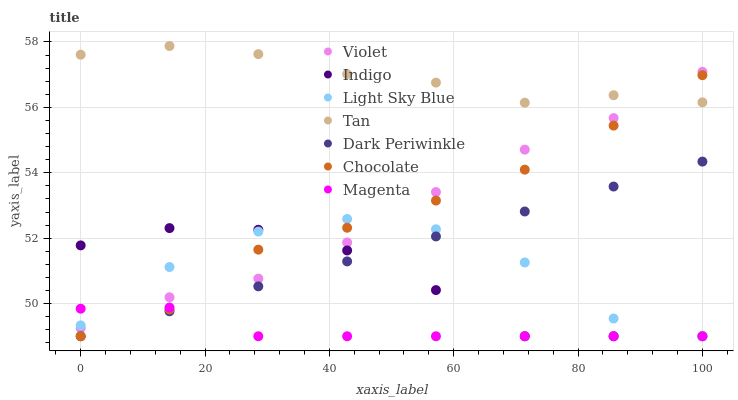Does Magenta have the minimum area under the curve?
Answer yes or no. Yes. Does Tan have the maximum area under the curve?
Answer yes or no. Yes. Does Chocolate have the minimum area under the curve?
Answer yes or no. No. Does Chocolate have the maximum area under the curve?
Answer yes or no. No. Is Dark Periwinkle the smoothest?
Answer yes or no. Yes. Is Light Sky Blue the roughest?
Answer yes or no. Yes. Is Chocolate the smoothest?
Answer yes or no. No. Is Chocolate the roughest?
Answer yes or no. No. Does Indigo have the lowest value?
Answer yes or no. Yes. Does Violet have the lowest value?
Answer yes or no. No. Does Tan have the highest value?
Answer yes or no. Yes. Does Chocolate have the highest value?
Answer yes or no. No. Is Dark Periwinkle less than Tan?
Answer yes or no. Yes. Is Tan greater than Dark Periwinkle?
Answer yes or no. Yes. Does Chocolate intersect Violet?
Answer yes or no. Yes. Is Chocolate less than Violet?
Answer yes or no. No. Is Chocolate greater than Violet?
Answer yes or no. No. Does Dark Periwinkle intersect Tan?
Answer yes or no. No. 